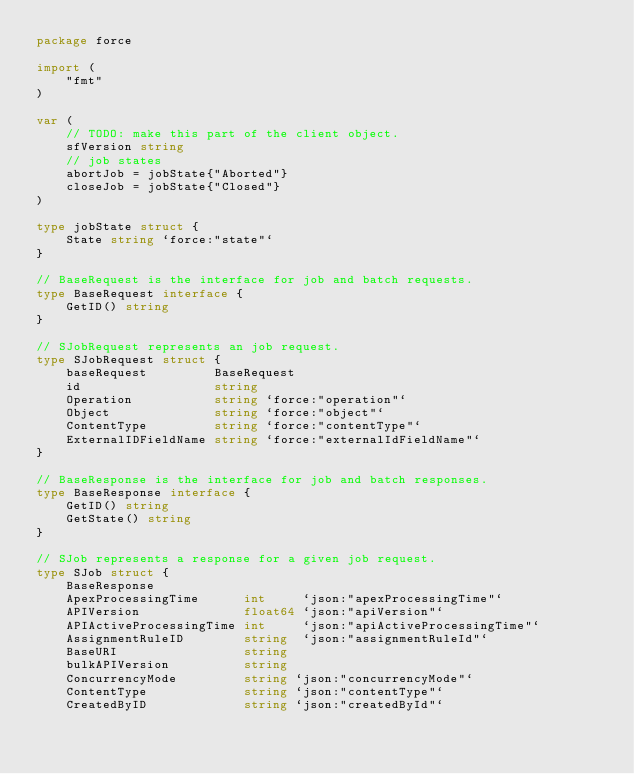<code> <loc_0><loc_0><loc_500><loc_500><_Go_>package force

import (
	"fmt"
)

var (
	// TODO: make this part of the client object.
	sfVersion string
	// job states
	abortJob = jobState{"Aborted"}
	closeJob = jobState{"Closed"}
)

type jobState struct {
	State string `force:"state"`
}

// BaseRequest is the interface for job and batch requests.
type BaseRequest interface {
	GetID() string
}

// SJobRequest represents an job request.
type SJobRequest struct {
	baseRequest         BaseRequest
	id                  string
	Operation           string `force:"operation"`
	Object              string `force:"object"`
	ContentType         string `force:"contentType"`
	ExternalIDFieldName string `force:"externalIdFieldName"`
}

// BaseResponse is the interface for job and batch responses.
type BaseResponse interface {
	GetID() string
	GetState() string
}

// SJob represents a response for a given job request.
type SJob struct {
	BaseResponse
	ApexProcessingTime      int     `json:"apexProcessingTime"`
	APIVersion              float64 `json:"apiVersion"`
	APIActiveProcessingTime int     `json:"apiActiveProcessingTime"`
	AssignmentRuleID        string  `json:"assignmentRuleId"`
	BaseURI                 string
	bulkAPIVersion          string
	ConcurrencyMode         string `json:"concurrencyMode"`
	ContentType             string `json:"contentType"`
	CreatedByID             string `json:"createdById"`</code> 